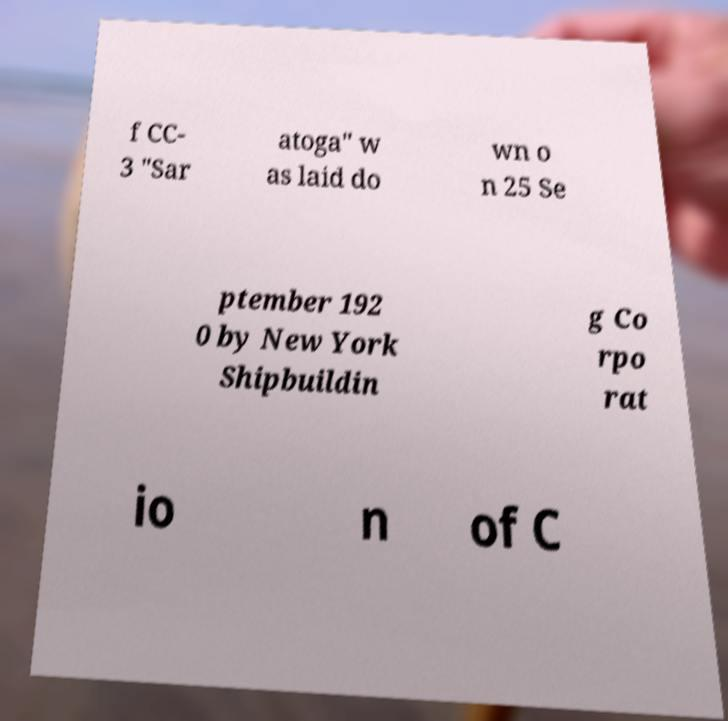Please identify and transcribe the text found in this image. f CC- 3 "Sar atoga" w as laid do wn o n 25 Se ptember 192 0 by New York Shipbuildin g Co rpo rat io n of C 